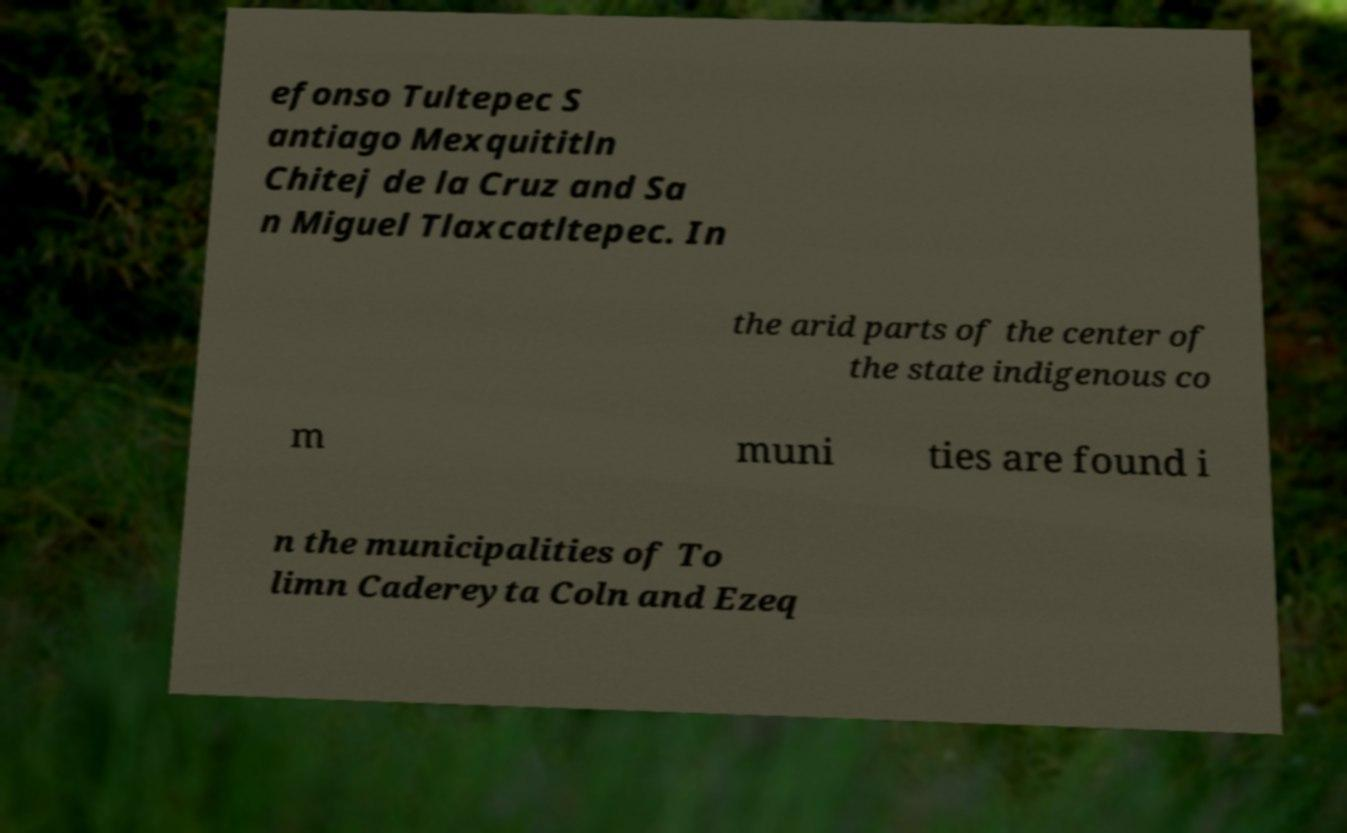Please read and relay the text visible in this image. What does it say? efonso Tultepec S antiago Mexquititln Chitej de la Cruz and Sa n Miguel Tlaxcatltepec. In the arid parts of the center of the state indigenous co m muni ties are found i n the municipalities of To limn Cadereyta Coln and Ezeq 